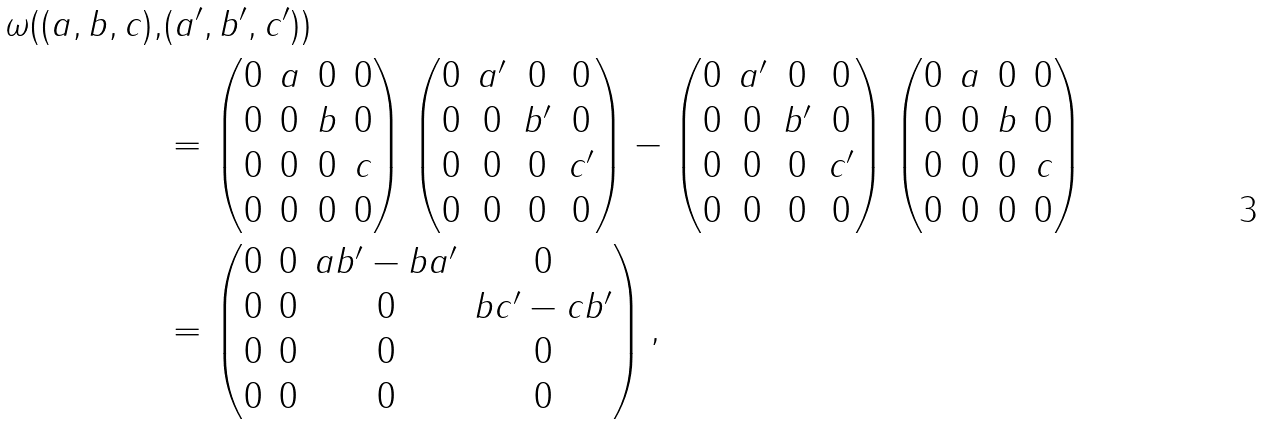Convert formula to latex. <formula><loc_0><loc_0><loc_500><loc_500>\omega ( ( a , b , c ) , & ( a ^ { \prime } , b ^ { \prime } , c ^ { \prime } ) ) \\ & = \begin{pmatrix} 0 & a & 0 & 0 \\ 0 & 0 & b & 0 \\ 0 & 0 & 0 & c \\ 0 & 0 & 0 & 0 \end{pmatrix} \begin{pmatrix} 0 & a ^ { \prime } & 0 & 0 \\ 0 & 0 & b ^ { \prime } & 0 \\ 0 & 0 & 0 & c ^ { \prime } \\ 0 & 0 & 0 & 0 \end{pmatrix} - \begin{pmatrix} 0 & a ^ { \prime } & 0 & 0 \\ 0 & 0 & b ^ { \prime } & 0 \\ 0 & 0 & 0 & c ^ { \prime } \\ 0 & 0 & 0 & 0 \end{pmatrix} \begin{pmatrix} 0 & a & 0 & 0 \\ 0 & 0 & b & 0 \\ 0 & 0 & 0 & c \\ 0 & 0 & 0 & 0 \end{pmatrix} \\ & = \begin{pmatrix} 0 & 0 & a b ^ { \prime } - b a ^ { \prime } & 0 \\ 0 & 0 & 0 & b c ^ { \prime } - c b ^ { \prime } \\ 0 & 0 & 0 & 0 \\ 0 & 0 & 0 & 0 \end{pmatrix} ,</formula> 